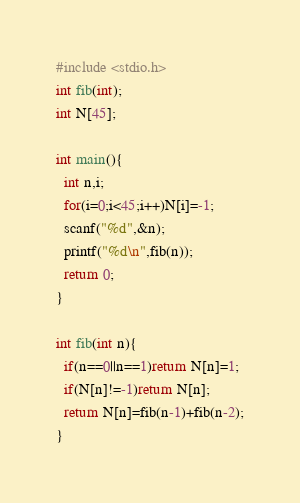Convert code to text. <code><loc_0><loc_0><loc_500><loc_500><_C_>#include <stdio.h>
int fib(int);
int N[45];

int main(){
  int n,i;
  for(i=0;i<45;i++)N[i]=-1;
  scanf("%d",&n);
  printf("%d\n",fib(n));
  return 0;
}

int fib(int n){
  if(n==0||n==1)return N[n]=1;
  if(N[n]!=-1)return N[n];
  return N[n]=fib(n-1)+fib(n-2);
}

</code> 